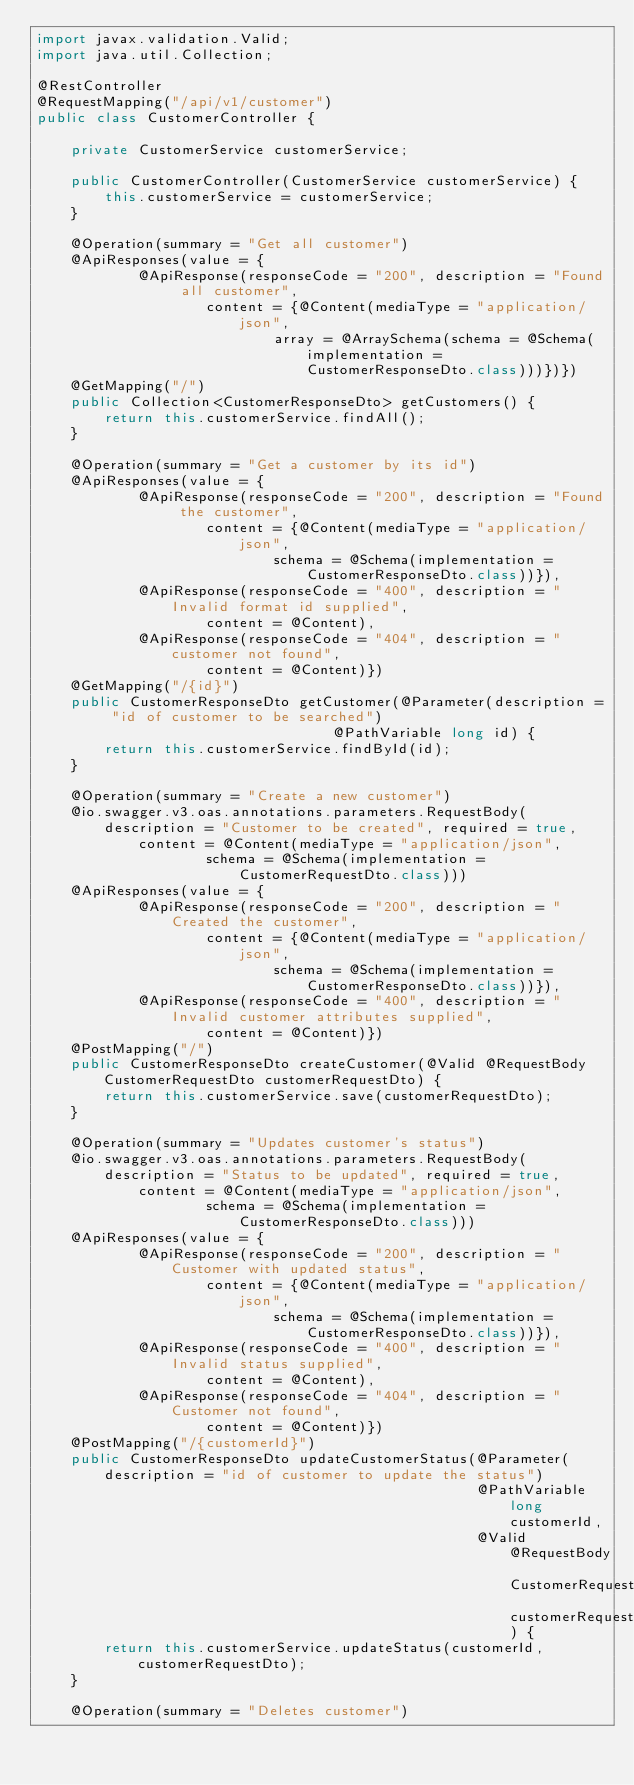Convert code to text. <code><loc_0><loc_0><loc_500><loc_500><_Java_>import javax.validation.Valid;
import java.util.Collection;

@RestController
@RequestMapping("/api/v1/customer")
public class CustomerController {

    private CustomerService customerService;

    public CustomerController(CustomerService customerService) {
        this.customerService = customerService;
    }

    @Operation(summary = "Get all customer")
    @ApiResponses(value = {
            @ApiResponse(responseCode = "200", description = "Found all customer",
                    content = {@Content(mediaType = "application/json",
                            array = @ArraySchema(schema = @Schema(implementation = CustomerResponseDto.class)))})})
    @GetMapping("/")
    public Collection<CustomerResponseDto> getCustomers() {
        return this.customerService.findAll();
    }

    @Operation(summary = "Get a customer by its id")
    @ApiResponses(value = {
            @ApiResponse(responseCode = "200", description = "Found the customer",
                    content = {@Content(mediaType = "application/json",
                            schema = @Schema(implementation = CustomerResponseDto.class))}),
            @ApiResponse(responseCode = "400", description = "Invalid format id supplied",
                    content = @Content),
            @ApiResponse(responseCode = "404", description = "customer not found",
                    content = @Content)})
    @GetMapping("/{id}")
    public CustomerResponseDto getCustomer(@Parameter(description = "id of customer to be searched")
                                   @PathVariable long id) {
        return this.customerService.findById(id);
    }

    @Operation(summary = "Create a new customer")
    @io.swagger.v3.oas.annotations.parameters.RequestBody(description = "Customer to be created", required = true,
            content = @Content(mediaType = "application/json",
                    schema = @Schema(implementation = CustomerRequestDto.class)))
    @ApiResponses(value = {
            @ApiResponse(responseCode = "200", description = "Created the customer",
                    content = {@Content(mediaType = "application/json",
                            schema = @Schema(implementation = CustomerResponseDto.class))}),
            @ApiResponse(responseCode = "400", description = "Invalid customer attributes supplied",
                    content = @Content)})
    @PostMapping("/")
    public CustomerResponseDto createCustomer(@Valid @RequestBody CustomerRequestDto customerRequestDto) {
        return this.customerService.save(customerRequestDto);
    }

    @Operation(summary = "Updates customer's status")
    @io.swagger.v3.oas.annotations.parameters.RequestBody(description = "Status to be updated", required = true,
            content = @Content(mediaType = "application/json",
                    schema = @Schema(implementation = CustomerResponseDto.class)))
    @ApiResponses(value = {
            @ApiResponse(responseCode = "200", description = "Customer with updated status",
                    content = {@Content(mediaType = "application/json",
                            schema = @Schema(implementation = CustomerResponseDto.class))}),
            @ApiResponse(responseCode = "400", description = "Invalid status supplied",
                    content = @Content),
            @ApiResponse(responseCode = "404", description = "Customer not found",
                    content = @Content)})
    @PostMapping("/{customerId}")
    public CustomerResponseDto updateCustomerStatus(@Parameter(description = "id of customer to update the status")
                                                    @PathVariable long customerId,
                                                    @Valid @RequestBody CustomerRequestDto customerRequestDto) {
        return this.customerService.updateStatus(customerId, customerRequestDto);
    }

    @Operation(summary = "Deletes customer")</code> 